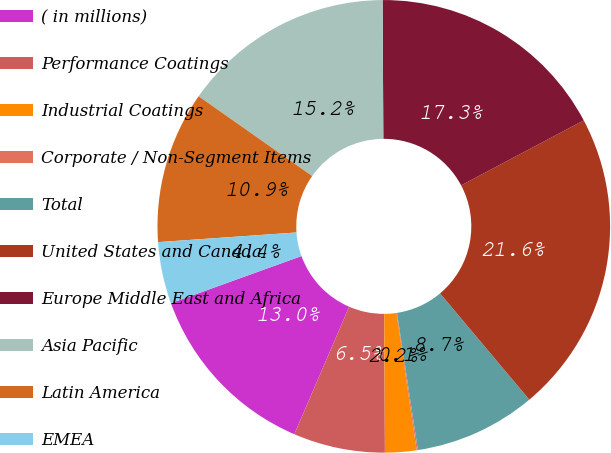Convert chart. <chart><loc_0><loc_0><loc_500><loc_500><pie_chart><fcel>( in millions)<fcel>Performance Coatings<fcel>Industrial Coatings<fcel>Corporate / Non-Segment Items<fcel>Total<fcel>United States and Canada<fcel>Europe Middle East and Africa<fcel>Asia Pacific<fcel>Latin America<fcel>EMEA<nl><fcel>13.02%<fcel>6.55%<fcel>2.24%<fcel>0.09%<fcel>8.71%<fcel>21.64%<fcel>17.33%<fcel>15.17%<fcel>10.86%<fcel>4.4%<nl></chart> 